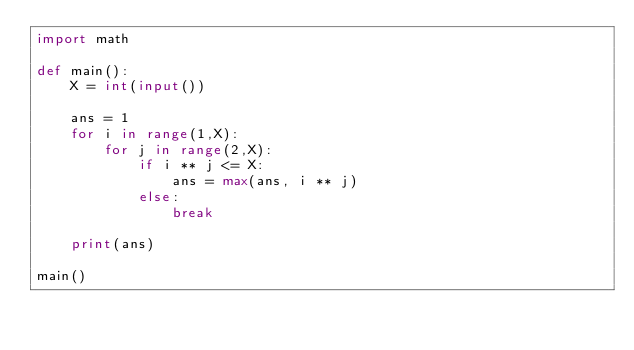Convert code to text. <code><loc_0><loc_0><loc_500><loc_500><_Python_>import math

def main():
    X = int(input())

    ans = 1
    for i in range(1,X):
        for j in range(2,X):
            if i ** j <= X:
                ans = max(ans, i ** j)
            else:
                break

    print(ans)

main()</code> 